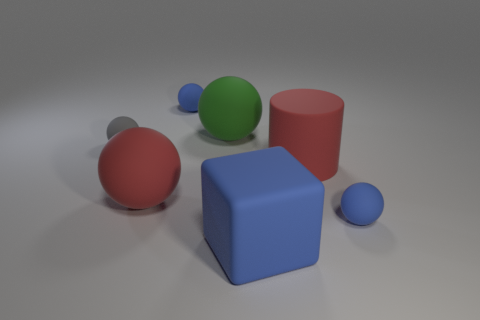The large cylinder that is in front of the blue rubber thing behind the object on the right side of the red matte cylinder is what color?
Ensure brevity in your answer.  Red. There is a small rubber sphere right of the small blue ball to the left of the cube; what is its color?
Your answer should be very brief. Blue. Are there more big cubes in front of the small gray rubber thing than big green objects behind the big blue matte object?
Your answer should be very brief. No. Does the tiny blue ball that is behind the large cylinder have the same material as the small object that is in front of the large red matte sphere?
Keep it short and to the point. Yes. There is a tiny gray ball; are there any rubber spheres behind it?
Your answer should be very brief. Yes. How many red things are either large rubber blocks or rubber cylinders?
Offer a very short reply. 1. Does the green sphere have the same material as the blue sphere right of the large blue rubber object?
Ensure brevity in your answer.  Yes. What is the size of the red object that is the same shape as the gray rubber thing?
Offer a very short reply. Large. What material is the cylinder?
Your answer should be compact. Rubber. There is a tiny blue thing that is behind the blue rubber ball to the right of the small blue thing left of the matte block; what is it made of?
Your answer should be very brief. Rubber. 